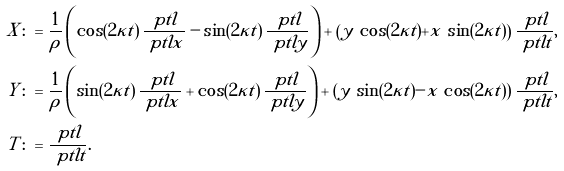Convert formula to latex. <formula><loc_0><loc_0><loc_500><loc_500>X \colon & = \frac { 1 } { \rho } \left ( \cos ( 2 \kappa t ) \, \frac { \ p t l } { \ p t l x } - \sin ( 2 \kappa t ) \, \frac { \ p t l } { \ p t l y } \right ) + \left ( y \, \cos ( 2 \kappa t ) + x \, \sin ( 2 \kappa t ) \right ) \frac { \ p t l } { \ p t l t } , \\ Y \colon & = \frac { 1 } { \rho } \left ( \sin ( 2 \kappa t ) \, \frac { \ p t l } { \ p t l x } + \cos ( 2 \kappa t ) \, \frac { \ p t l } { \ p t l y } \right ) + \left ( y \, \sin ( 2 \kappa t ) - x \, \cos ( 2 \kappa t ) \right ) \frac { \ p t l } { \ p t l t } , \\ T \colon & = \frac { \ p t l } { \ p t l t } .</formula> 